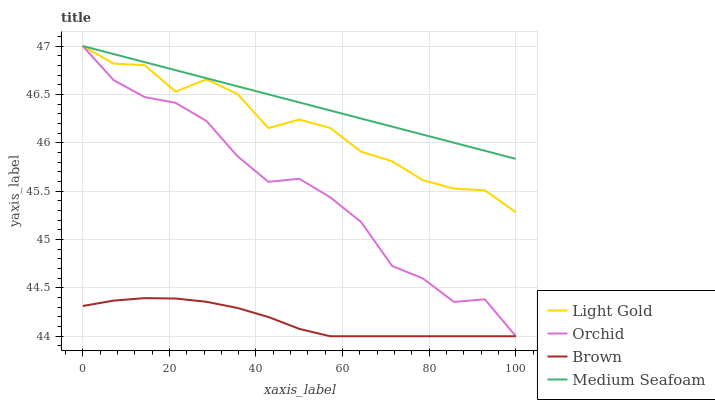Does Brown have the minimum area under the curve?
Answer yes or no. Yes. Does Medium Seafoam have the maximum area under the curve?
Answer yes or no. Yes. Does Light Gold have the minimum area under the curve?
Answer yes or no. No. Does Light Gold have the maximum area under the curve?
Answer yes or no. No. Is Medium Seafoam the smoothest?
Answer yes or no. Yes. Is Light Gold the roughest?
Answer yes or no. Yes. Is Light Gold the smoothest?
Answer yes or no. No. Is Medium Seafoam the roughest?
Answer yes or no. No. Does Brown have the lowest value?
Answer yes or no. Yes. Does Light Gold have the lowest value?
Answer yes or no. No. Does Orchid have the highest value?
Answer yes or no. Yes. Is Brown less than Medium Seafoam?
Answer yes or no. Yes. Is Light Gold greater than Brown?
Answer yes or no. Yes. Does Brown intersect Orchid?
Answer yes or no. Yes. Is Brown less than Orchid?
Answer yes or no. No. Is Brown greater than Orchid?
Answer yes or no. No. Does Brown intersect Medium Seafoam?
Answer yes or no. No. 